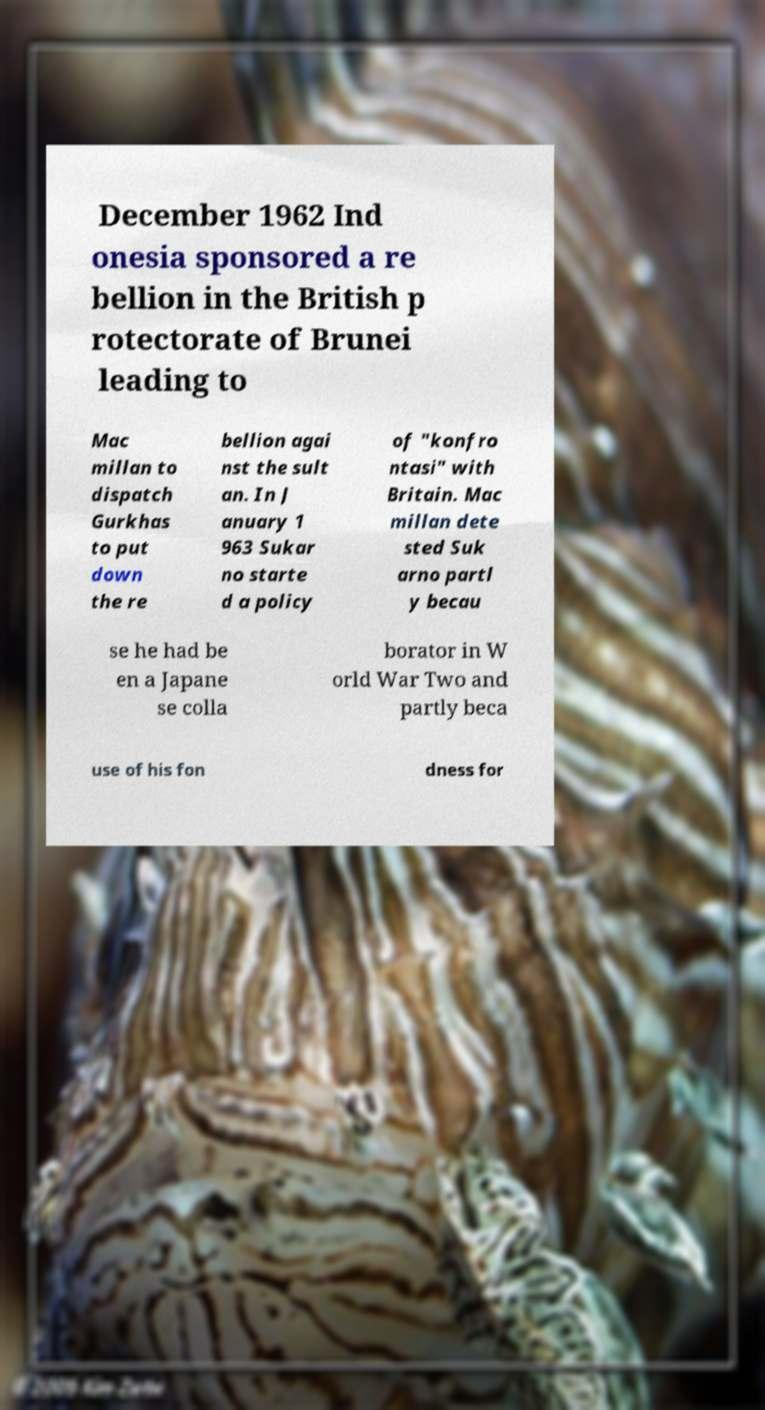Could you extract and type out the text from this image? December 1962 Ind onesia sponsored a re bellion in the British p rotectorate of Brunei leading to Mac millan to dispatch Gurkhas to put down the re bellion agai nst the sult an. In J anuary 1 963 Sukar no starte d a policy of "konfro ntasi" with Britain. Mac millan dete sted Suk arno partl y becau se he had be en a Japane se colla borator in W orld War Two and partly beca use of his fon dness for 